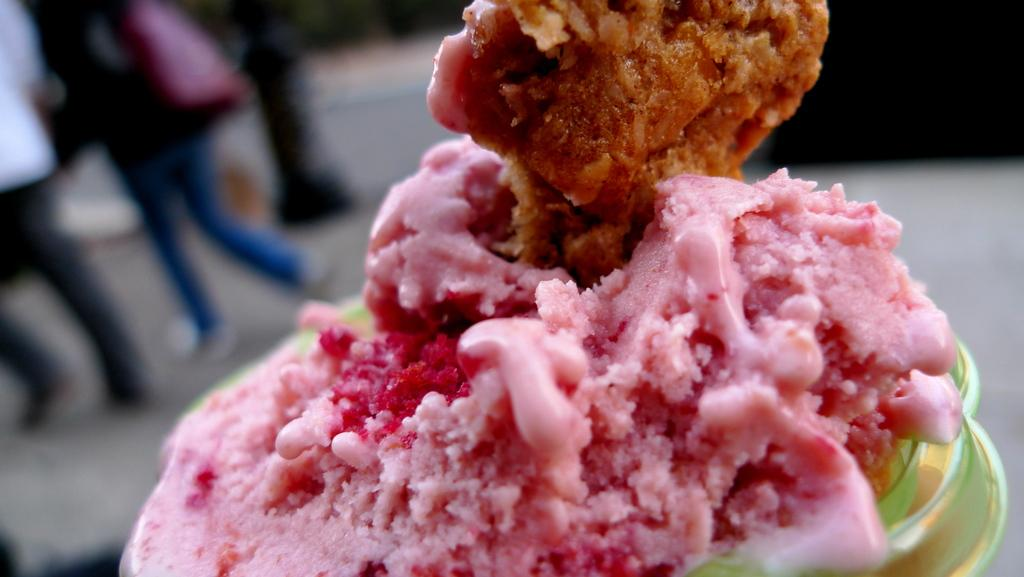What can be seen in the image related to food? There is food in the image. What type of straw is used to sew the fire in the image? There is no straw, thread, or fire present in the image. The image only contains food. 